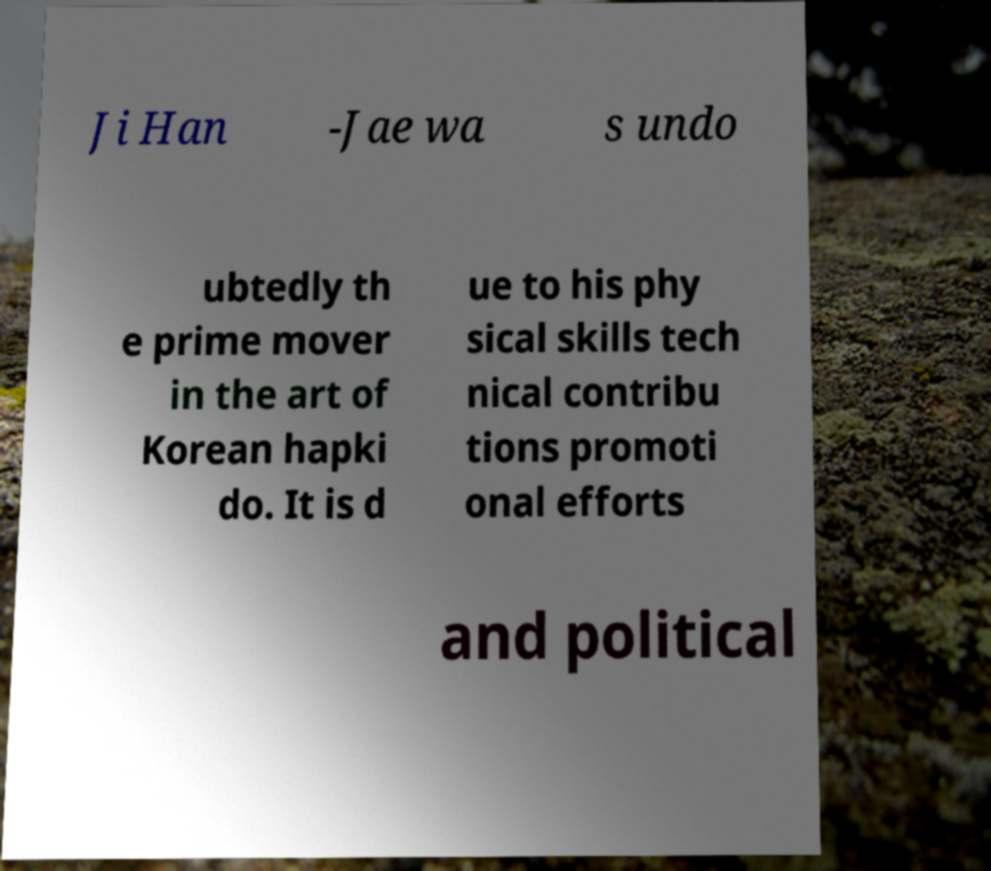Could you assist in decoding the text presented in this image and type it out clearly? Ji Han -Jae wa s undo ubtedly th e prime mover in the art of Korean hapki do. It is d ue to his phy sical skills tech nical contribu tions promoti onal efforts and political 